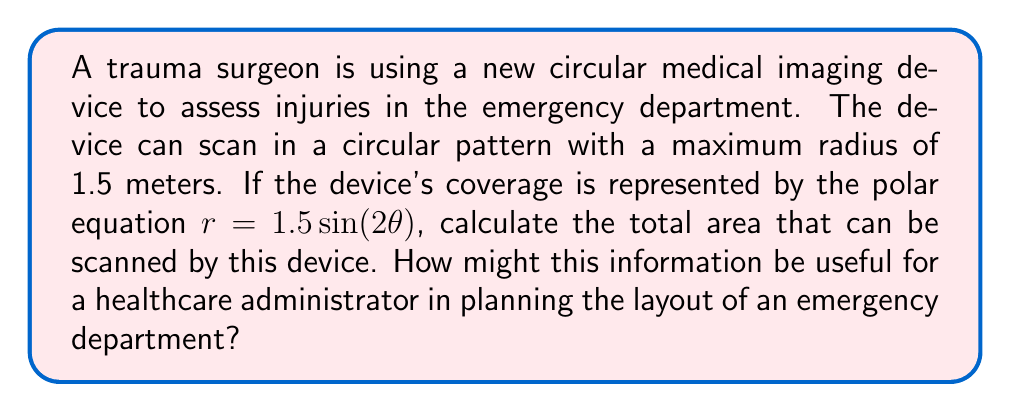Help me with this question. To solve this problem, we need to use the formula for area in polar coordinates and integrate over the appropriate interval. The steps are as follows:

1) The formula for area in polar coordinates is:

   $$A = \frac{1}{2} \int_a^b r^2 d\theta$$

2) In this case, $r = 1.5 \sin(2\theta)$, so we need to square this:

   $$r^2 = (1.5 \sin(2\theta))^2 = 2.25 \sin^2(2\theta)$$

3) The limits of integration will be from 0 to $\pi$, as this covers the full range of the function (note that $\sin(2\theta)$ has a period of $\pi$).

4) Substituting into the area formula:

   $$A = \frac{1}{2} \int_0^\pi 2.25 \sin^2(2\theta) d\theta$$

5) Simplify:

   $$A = \frac{9}{8} \int_0^\pi \sin^2(2\theta) d\theta$$

6) Use the identity $\sin^2(x) = \frac{1}{2}(1 - \cos(2x))$:

   $$A = \frac{9}{8} \int_0^\pi \frac{1}{2}(1 - \cos(4\theta)) d\theta$$

7) Integrate:

   $$A = \frac{9}{16} [\theta - \frac{1}{4}\sin(4\theta)]_0^\pi$$

8) Evaluate:

   $$A = \frac{9}{16} [\pi - 0 - (0 - 0)] = \frac{9\pi}{16} \approx 1.77 \text{ square meters}$$

For a healthcare administrator, this information is crucial for several reasons:

1) It helps in understanding the space requirements for the equipment, which is essential for efficient room layout planning.
2) It aids in determining how many such devices might be needed to cover the emergency department effectively.
3) It assists in planning patient flow and positioning, ensuring that patients can be scanned efficiently without unnecessary movement.
4) This knowledge can help in comparing different imaging devices and their coverage areas when making procurement decisions.
Answer: The total area that can be scanned by the device is $\frac{9\pi}{16} \approx 1.77 \text{ square meters}$. 